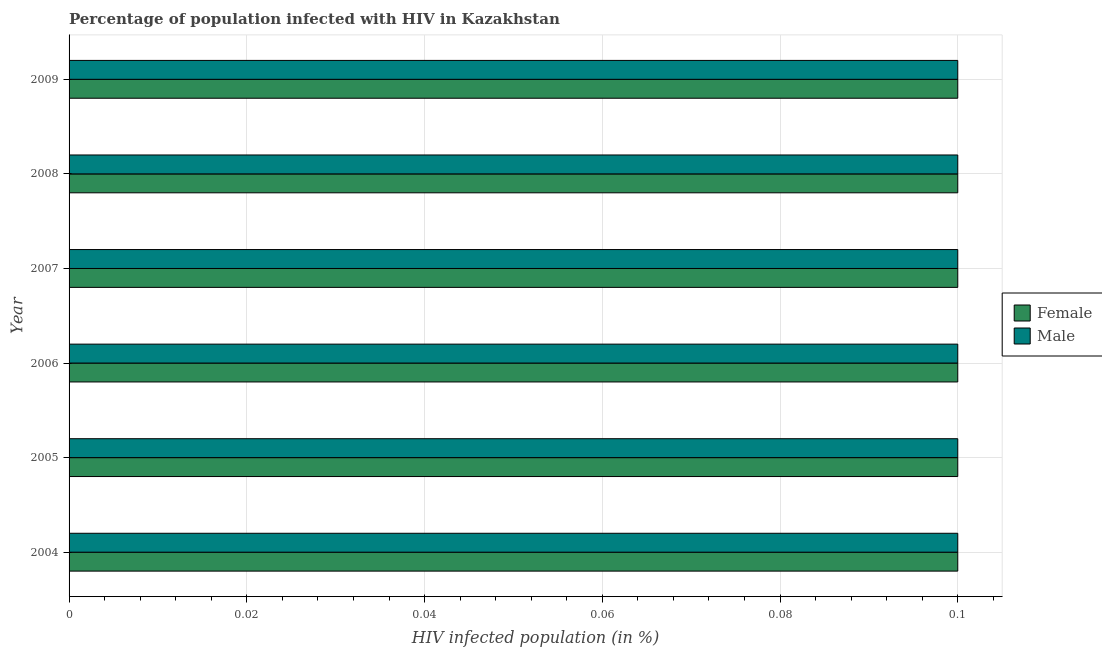In how many cases, is the number of bars for a given year not equal to the number of legend labels?
Ensure brevity in your answer.  0. What is the percentage of females who are infected with hiv in 2007?
Your response must be concise. 0.1. In which year was the percentage of females who are infected with hiv maximum?
Offer a very short reply. 2004. In which year was the percentage of males who are infected with hiv minimum?
Offer a very short reply. 2004. What is the difference between the percentage of males who are infected with hiv in 2006 and that in 2009?
Your response must be concise. 0. In the year 2004, what is the difference between the percentage of males who are infected with hiv and percentage of females who are infected with hiv?
Offer a very short reply. 0. In how many years, is the percentage of males who are infected with hiv greater than 0.036000000000000004 %?
Give a very brief answer. 6. Is the percentage of males who are infected with hiv in 2004 less than that in 2005?
Ensure brevity in your answer.  No. What is the difference between the highest and the lowest percentage of males who are infected with hiv?
Give a very brief answer. 0. In how many years, is the percentage of females who are infected with hiv greater than the average percentage of females who are infected with hiv taken over all years?
Provide a succinct answer. 6. Is the sum of the percentage of females who are infected with hiv in 2004 and 2007 greater than the maximum percentage of males who are infected with hiv across all years?
Ensure brevity in your answer.  Yes. Are all the bars in the graph horizontal?
Provide a succinct answer. Yes. What is the difference between two consecutive major ticks on the X-axis?
Provide a short and direct response. 0.02. Does the graph contain grids?
Offer a terse response. Yes. Where does the legend appear in the graph?
Offer a terse response. Center right. How many legend labels are there?
Make the answer very short. 2. What is the title of the graph?
Offer a very short reply. Percentage of population infected with HIV in Kazakhstan. What is the label or title of the X-axis?
Provide a short and direct response. HIV infected population (in %). What is the HIV infected population (in %) of Male in 2004?
Provide a succinct answer. 0.1. What is the HIV infected population (in %) of Female in 2005?
Provide a succinct answer. 0.1. What is the HIV infected population (in %) in Male in 2006?
Offer a terse response. 0.1. What is the HIV infected population (in %) of Female in 2007?
Ensure brevity in your answer.  0.1. What is the HIV infected population (in %) of Male in 2007?
Give a very brief answer. 0.1. What is the HIV infected population (in %) of Male in 2008?
Ensure brevity in your answer.  0.1. What is the HIV infected population (in %) of Female in 2009?
Offer a terse response. 0.1. What is the HIV infected population (in %) in Male in 2009?
Offer a terse response. 0.1. Across all years, what is the minimum HIV infected population (in %) of Male?
Your response must be concise. 0.1. What is the total HIV infected population (in %) in Male in the graph?
Give a very brief answer. 0.6. What is the difference between the HIV infected population (in %) in Female in 2004 and that in 2005?
Offer a very short reply. 0. What is the difference between the HIV infected population (in %) of Male in 2004 and that in 2006?
Keep it short and to the point. 0. What is the difference between the HIV infected population (in %) of Female in 2004 and that in 2007?
Ensure brevity in your answer.  0. What is the difference between the HIV infected population (in %) in Male in 2004 and that in 2007?
Offer a terse response. 0. What is the difference between the HIV infected population (in %) in Female in 2004 and that in 2009?
Make the answer very short. 0. What is the difference between the HIV infected population (in %) of Female in 2005 and that in 2006?
Your answer should be very brief. 0. What is the difference between the HIV infected population (in %) in Male in 2005 and that in 2006?
Make the answer very short. 0. What is the difference between the HIV infected population (in %) in Female in 2005 and that in 2007?
Your answer should be very brief. 0. What is the difference between the HIV infected population (in %) of Male in 2005 and that in 2008?
Ensure brevity in your answer.  0. What is the difference between the HIV infected population (in %) of Female in 2006 and that in 2008?
Your answer should be compact. 0. What is the difference between the HIV infected population (in %) in Female in 2006 and that in 2009?
Keep it short and to the point. 0. What is the difference between the HIV infected population (in %) in Female in 2007 and that in 2008?
Your answer should be very brief. 0. What is the difference between the HIV infected population (in %) of Male in 2007 and that in 2008?
Provide a short and direct response. 0. What is the difference between the HIV infected population (in %) in Female in 2007 and that in 2009?
Provide a succinct answer. 0. What is the difference between the HIV infected population (in %) of Male in 2007 and that in 2009?
Keep it short and to the point. 0. What is the difference between the HIV infected population (in %) in Female in 2008 and that in 2009?
Make the answer very short. 0. What is the difference between the HIV infected population (in %) of Female in 2004 and the HIV infected population (in %) of Male in 2005?
Provide a succinct answer. 0. What is the difference between the HIV infected population (in %) in Female in 2004 and the HIV infected population (in %) in Male in 2006?
Your answer should be very brief. 0. What is the difference between the HIV infected population (in %) in Female in 2004 and the HIV infected population (in %) in Male in 2007?
Give a very brief answer. 0. What is the difference between the HIV infected population (in %) in Female in 2004 and the HIV infected population (in %) in Male in 2009?
Provide a succinct answer. 0. What is the difference between the HIV infected population (in %) in Female in 2005 and the HIV infected population (in %) in Male in 2007?
Provide a short and direct response. 0. What is the difference between the HIV infected population (in %) in Female in 2005 and the HIV infected population (in %) in Male in 2009?
Provide a succinct answer. 0. What is the difference between the HIV infected population (in %) of Female in 2006 and the HIV infected population (in %) of Male in 2007?
Give a very brief answer. 0. What is the difference between the HIV infected population (in %) of Female in 2006 and the HIV infected population (in %) of Male in 2008?
Ensure brevity in your answer.  0. What is the average HIV infected population (in %) of Female per year?
Provide a short and direct response. 0.1. In the year 2006, what is the difference between the HIV infected population (in %) in Female and HIV infected population (in %) in Male?
Offer a very short reply. 0. In the year 2009, what is the difference between the HIV infected population (in %) in Female and HIV infected population (in %) in Male?
Your answer should be compact. 0. What is the ratio of the HIV infected population (in %) of Male in 2004 to that in 2006?
Provide a short and direct response. 1. What is the ratio of the HIV infected population (in %) of Female in 2005 to that in 2006?
Your response must be concise. 1. What is the ratio of the HIV infected population (in %) in Male in 2005 to that in 2006?
Provide a succinct answer. 1. What is the ratio of the HIV infected population (in %) of Male in 2005 to that in 2008?
Give a very brief answer. 1. What is the ratio of the HIV infected population (in %) in Male in 2005 to that in 2009?
Offer a terse response. 1. What is the ratio of the HIV infected population (in %) of Male in 2006 to that in 2008?
Your answer should be compact. 1. What is the ratio of the HIV infected population (in %) of Female in 2006 to that in 2009?
Keep it short and to the point. 1. What is the ratio of the HIV infected population (in %) of Male in 2007 to that in 2008?
Give a very brief answer. 1. What is the ratio of the HIV infected population (in %) of Female in 2007 to that in 2009?
Your answer should be compact. 1. What is the ratio of the HIV infected population (in %) in Male in 2007 to that in 2009?
Offer a terse response. 1. What is the difference between the highest and the second highest HIV infected population (in %) of Male?
Ensure brevity in your answer.  0. What is the difference between the highest and the lowest HIV infected population (in %) of Female?
Your answer should be compact. 0. 